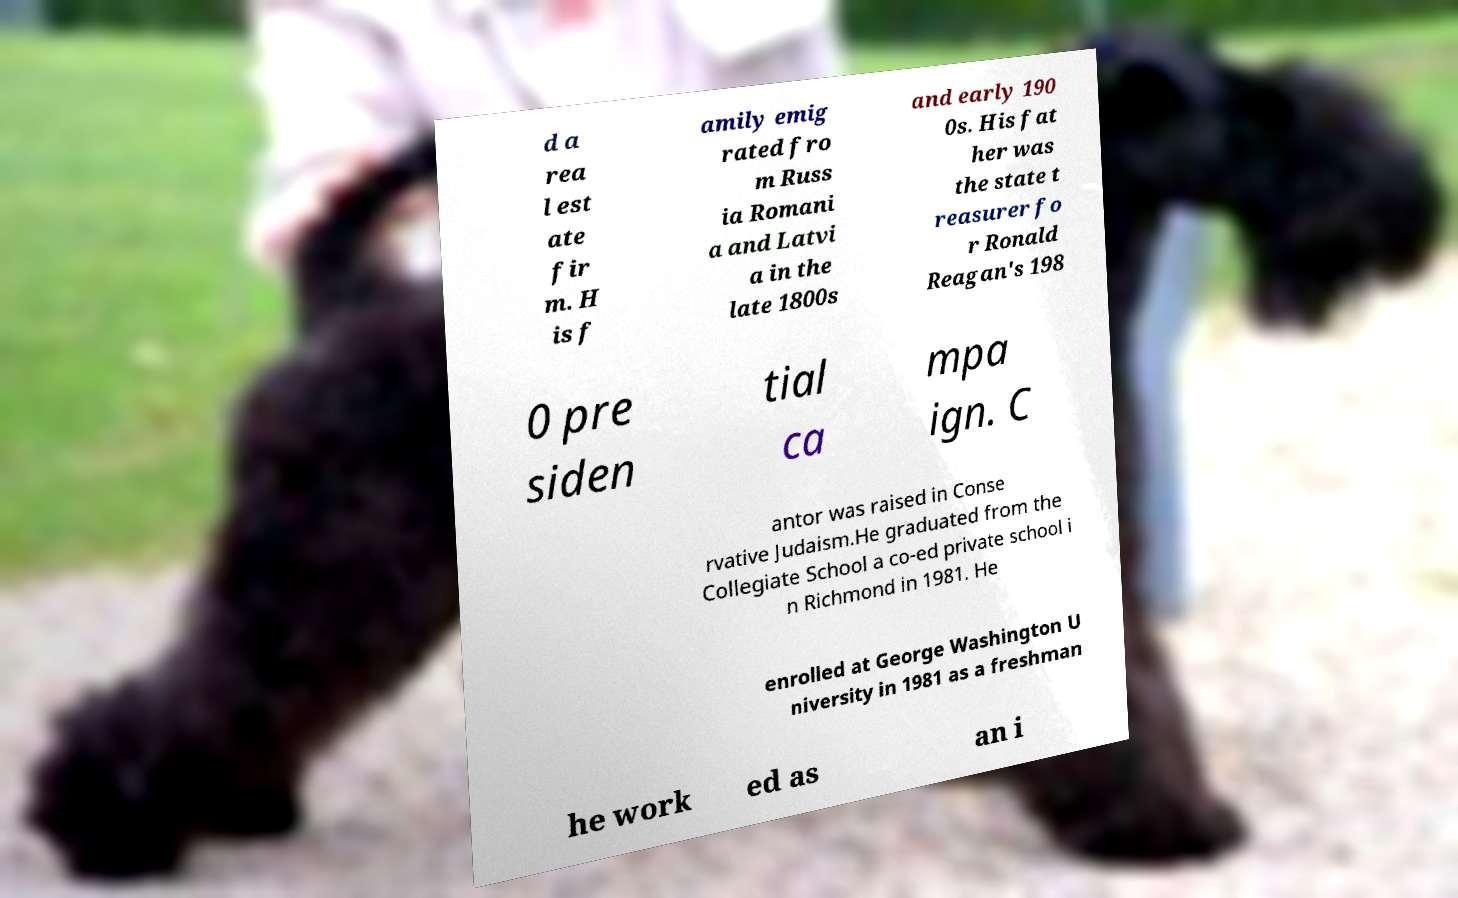For documentation purposes, I need the text within this image transcribed. Could you provide that? d a rea l est ate fir m. H is f amily emig rated fro m Russ ia Romani a and Latvi a in the late 1800s and early 190 0s. His fat her was the state t reasurer fo r Ronald Reagan's 198 0 pre siden tial ca mpa ign. C antor was raised in Conse rvative Judaism.He graduated from the Collegiate School a co-ed private school i n Richmond in 1981. He enrolled at George Washington U niversity in 1981 as a freshman he work ed as an i 